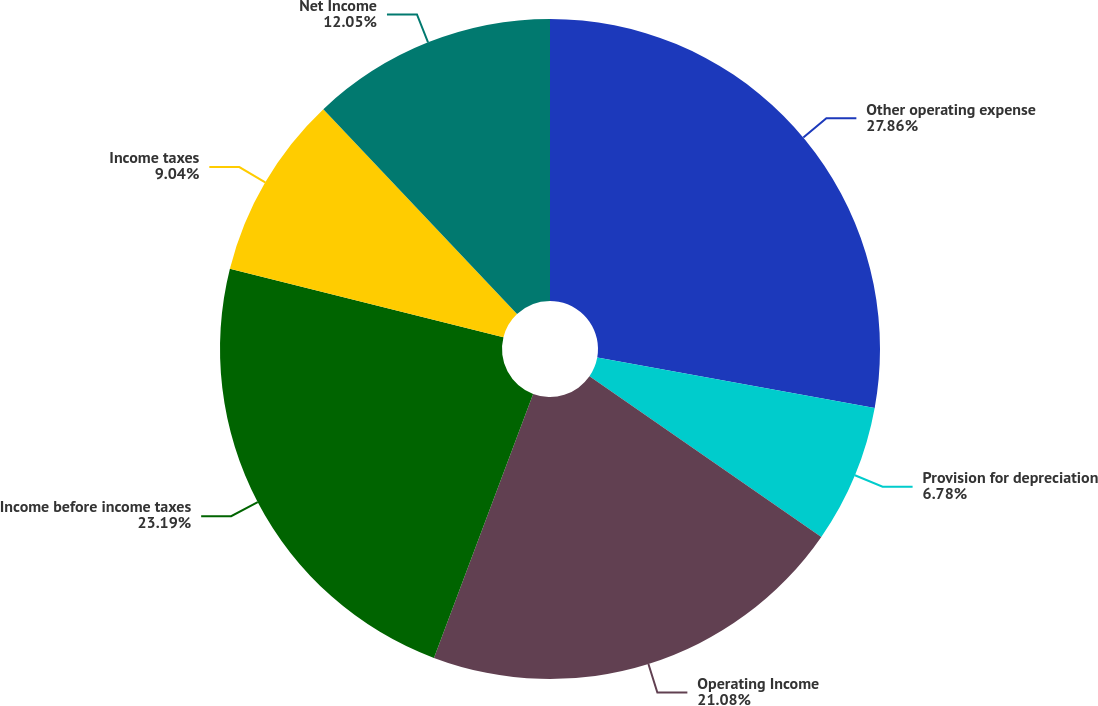Convert chart. <chart><loc_0><loc_0><loc_500><loc_500><pie_chart><fcel>Other operating expense<fcel>Provision for depreciation<fcel>Operating Income<fcel>Income before income taxes<fcel>Income taxes<fcel>Net Income<nl><fcel>27.86%<fcel>6.78%<fcel>21.08%<fcel>23.19%<fcel>9.04%<fcel>12.05%<nl></chart> 